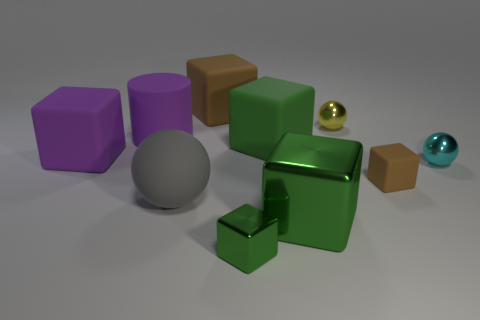Subtract all red balls. How many green blocks are left? 3 Subtract all brown blocks. How many blocks are left? 4 Subtract all purple cubes. How many cubes are left? 5 Subtract all yellow blocks. Subtract all brown spheres. How many blocks are left? 6 Subtract all blocks. How many objects are left? 4 Add 4 metallic cubes. How many metallic cubes are left? 6 Add 6 tiny cubes. How many tiny cubes exist? 8 Subtract 3 green blocks. How many objects are left? 7 Subtract all green shiny cubes. Subtract all big shiny things. How many objects are left? 7 